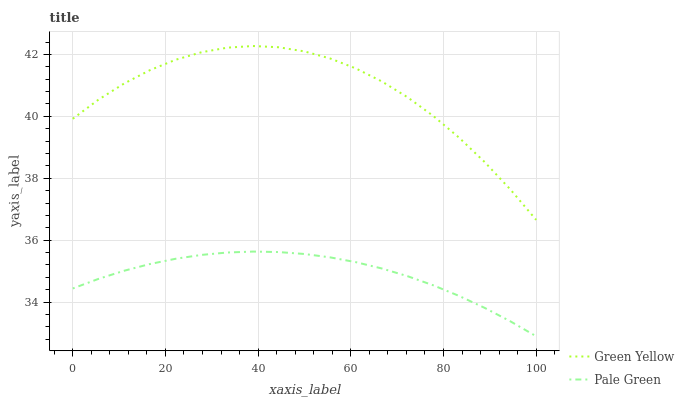Does Pale Green have the minimum area under the curve?
Answer yes or no. Yes. Does Green Yellow have the maximum area under the curve?
Answer yes or no. Yes. Does Green Yellow have the minimum area under the curve?
Answer yes or no. No. Is Pale Green the smoothest?
Answer yes or no. Yes. Is Green Yellow the roughest?
Answer yes or no. Yes. Is Green Yellow the smoothest?
Answer yes or no. No. Does Green Yellow have the lowest value?
Answer yes or no. No. Is Pale Green less than Green Yellow?
Answer yes or no. Yes. Is Green Yellow greater than Pale Green?
Answer yes or no. Yes. Does Pale Green intersect Green Yellow?
Answer yes or no. No. 